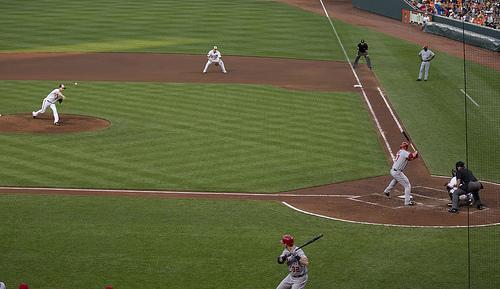How many people are holding bats?
Give a very brief answer. 2. 